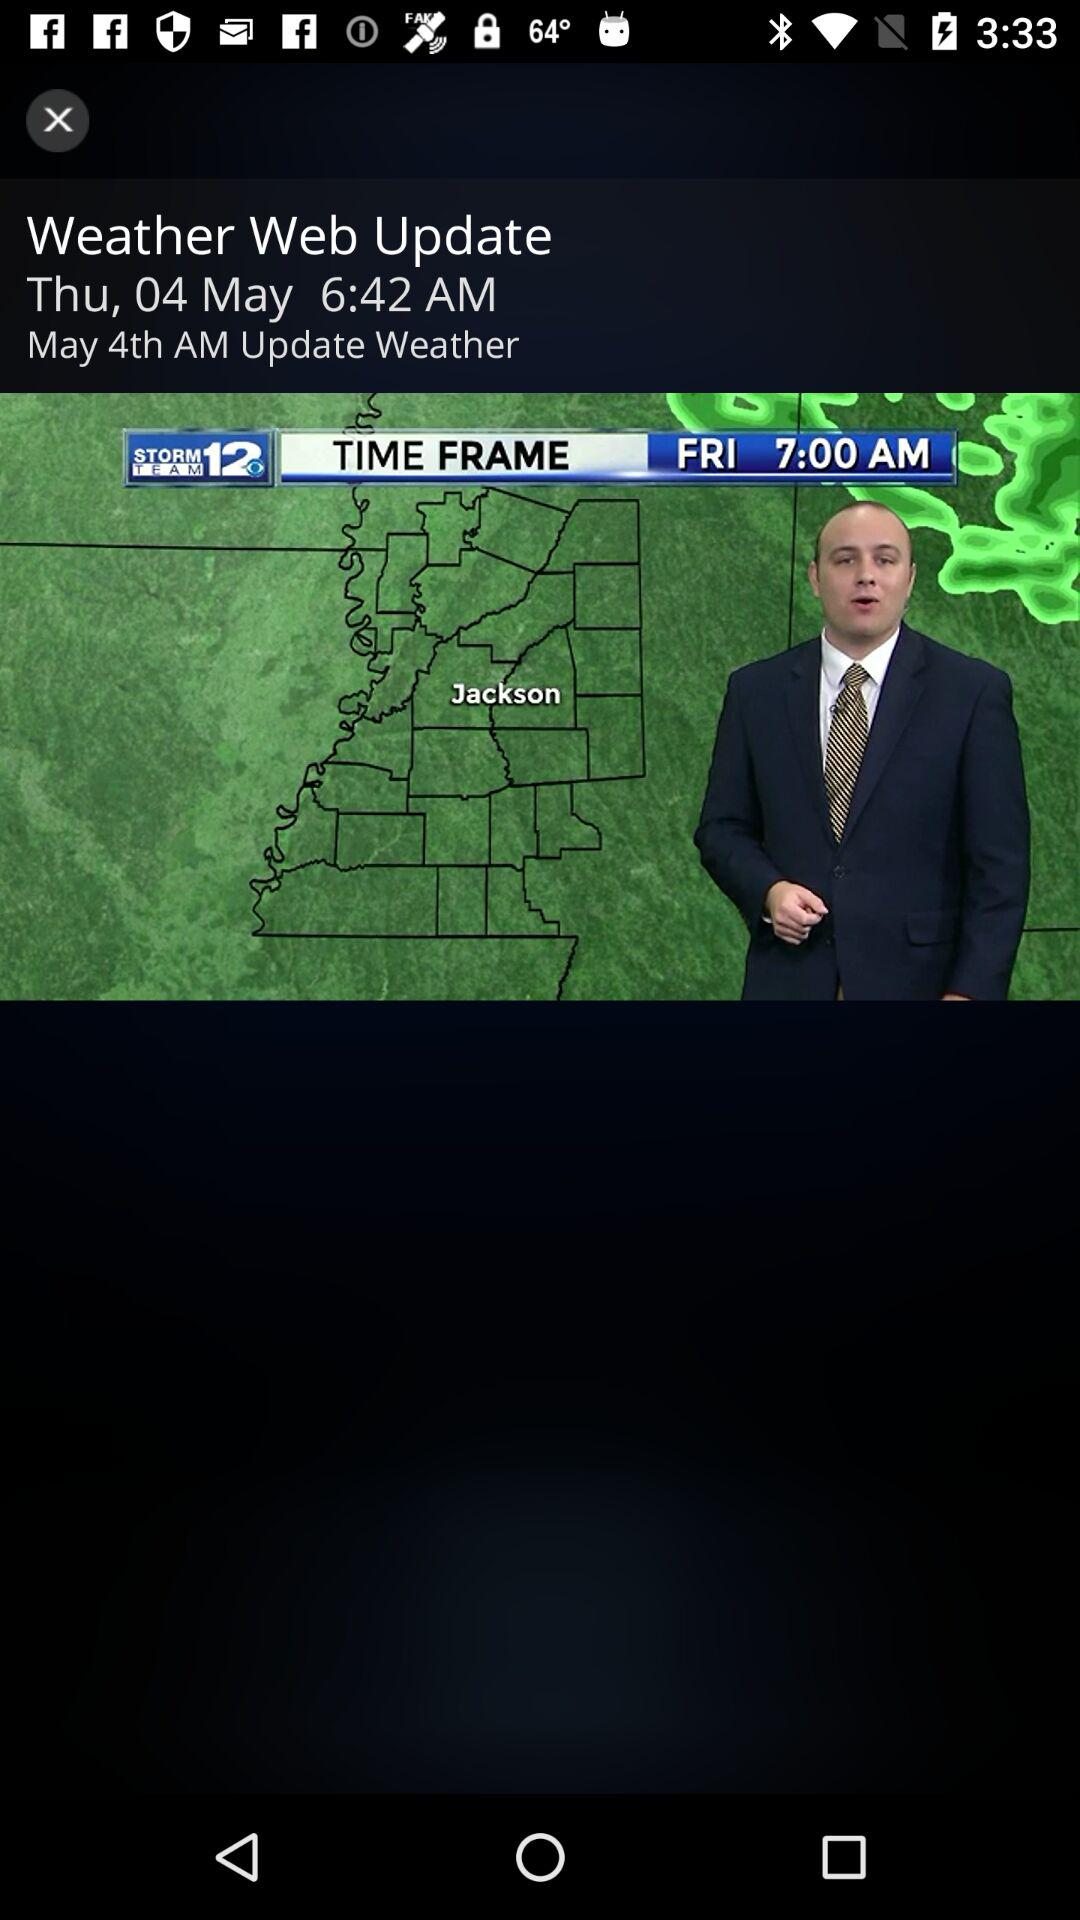What is the date and time of the "Weather Web Update"? The date and time is Thursday, May 4 at 6:42 a.m. 